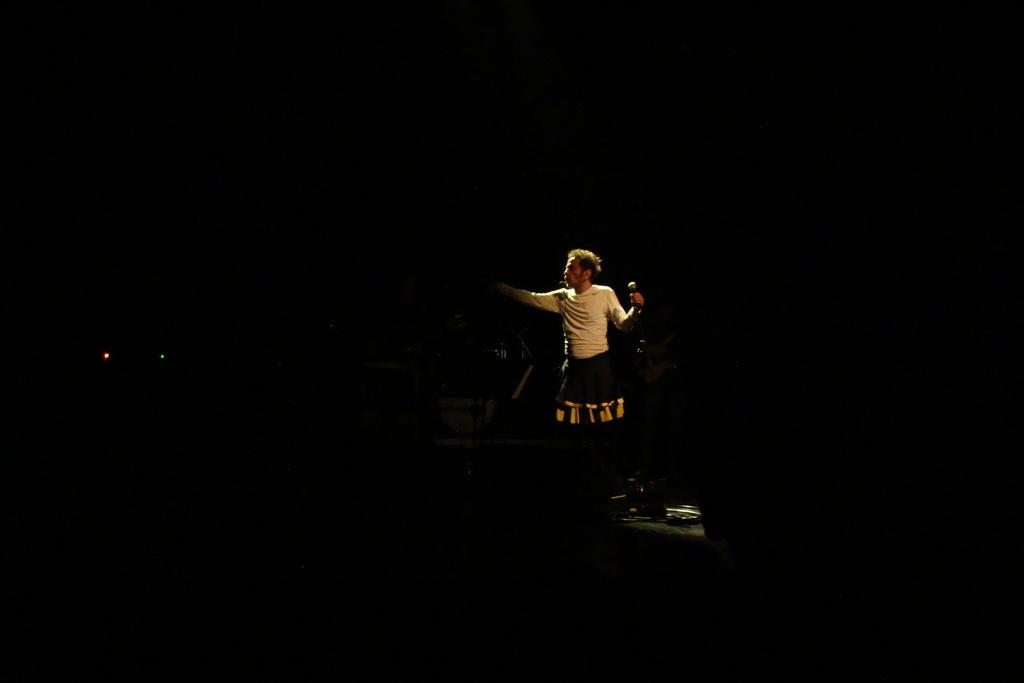What is the man in the image doing? The man is standing in the image and holding a microphone. What can be seen in the man's hand? The man is holding a microphone. What is visible in the image besides the man? There are lights visible in the image. What color is the background of the image? The background of the image is black. What type of cake is being served at the religious ceremony in the image? There is no cake or religious ceremony present in the image; it features a man holding a microphone with lights and a black background. What does the image smell like? Images do not have a smell, so it is not possible to determine what the image smells like. 